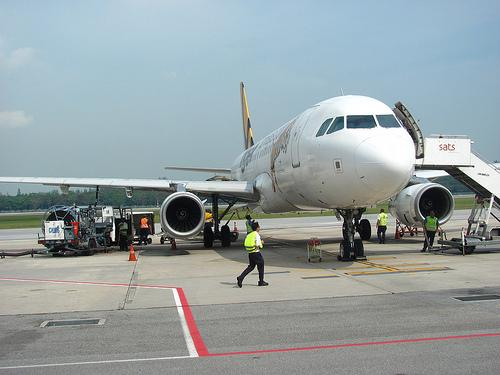Write a sentence describing the main focal point of the image. A large white airplane is stationed on the runway, surrounded by working personnel, traffic cones, and boarding stairs. Describe the weather in the image and its impact on the scene. The scene takes place under a blue sky with white clouds, providing a natural backdrop for the airport runway, airplane, and workers. Identify the workers in the image and explain their role. Airport workers wearing neon green and orange safety vests are present, performing maintenance and helping with boarding procedures for the airplane. Describe what you see in the image focusing on the compositions and colors. A white airplane on a gray tarmac with red and white lines, orange traffic cones, blue sky with clouds, airport workers wearing neon green vests, and portable stairs. Describe the location where the image is taking place. This image takes place on an airport runway, where a white airplane is parked with airport workers, passenger loading steps, and safety cones nearby. Mention the type of vehicle in the image and any related objects surrounding it. An airplane on the runway, surrounded by orange safety cones, airport workers in neon vests, and portable passenger loading steps. Identify any safety precautions visible in the image. Safety precautions include airport workers wearing neon green and orange safety vests and orange traffic cones placed around the airplane on the runway. Mention the main transportation theme in the image and include some details about it. The airplane on the runway is the main transportation focus, with visible left and right jet engines, wings, and boarding stairs attached to it. Write a brief description of the scene, highlighting any relevant objects. The scene features a parked airplane on a runway, accompanied by airport workers in safety vests, orange traffic cones, portable stairs, and a visible blue sky with clouds. Provide a brief overview of the main elements in the image. A large white airplane on the runway with engine and wing details, orange traffic cones, airport workers wearing safety vests, and passenger loading steps. 